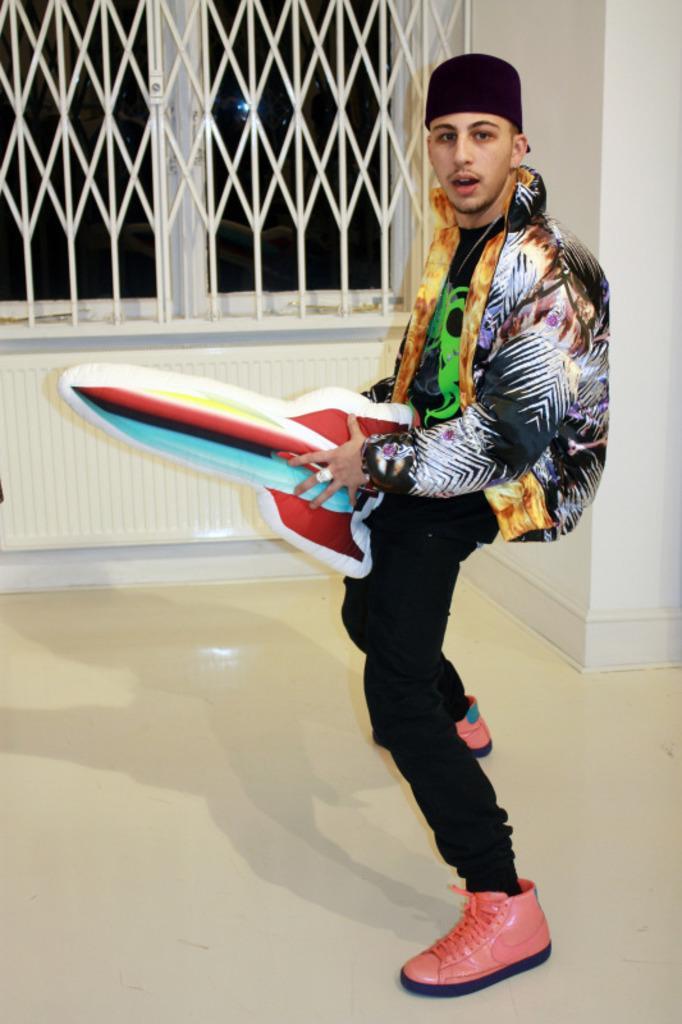Could you give a brief overview of what you see in this image? In this picture we can see a man wore a cap, shoes and holding a balloon rocket with his hands and standing on the floor and in the background we can see rods, window, walls. 